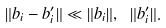<formula> <loc_0><loc_0><loc_500><loc_500>\| b _ { i } - b _ { i } ^ { \prime } \| \ll \| b _ { i } \| , \ \| b _ { i } ^ { \prime } \| .</formula> 